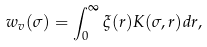Convert formula to latex. <formula><loc_0><loc_0><loc_500><loc_500>w _ { v } ( \sigma ) = \int _ { 0 } ^ { \infty } \xi ( r ) K ( \sigma , r ) d r ,</formula> 